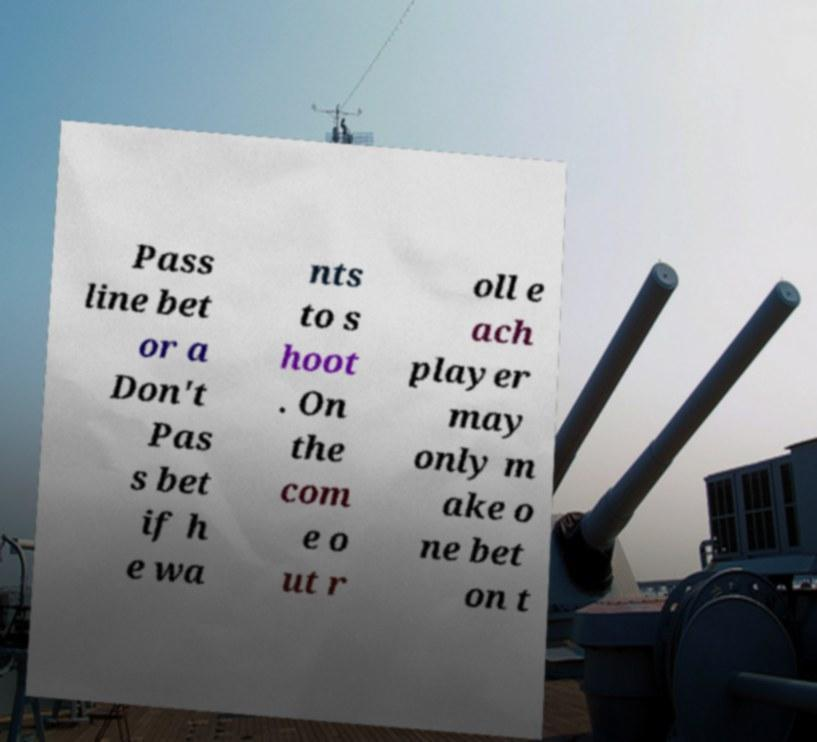What messages or text are displayed in this image? I need them in a readable, typed format. Pass line bet or a Don't Pas s bet if h e wa nts to s hoot . On the com e o ut r oll e ach player may only m ake o ne bet on t 